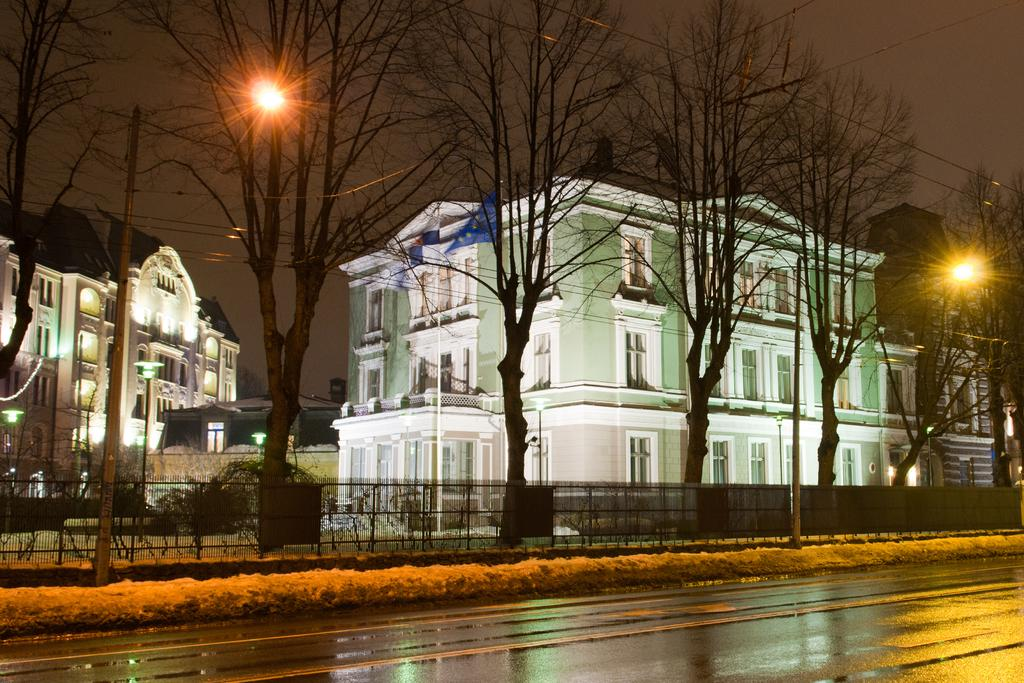What is the main feature of the image? There is a road in the image. What can be seen near the road? Railings and trees are visible near the road. Are there any light sources in the image? Yes, lights are present in the image. What else can be seen in the image? Poles are visible in the image. What is visible in the background of the image? There are buildings with windows in the background of the image. Can you see any corn growing near the road in the image? There is no corn visible in the image. Is there a prison visible in the background of the image? There is no prison present in the image; only buildings with windows are visible in the background. 